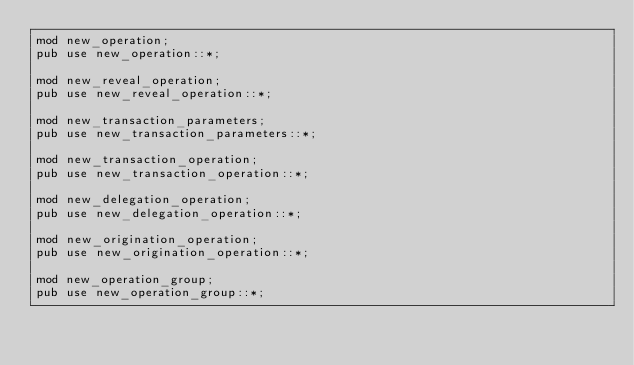Convert code to text. <code><loc_0><loc_0><loc_500><loc_500><_Rust_>mod new_operation;
pub use new_operation::*;

mod new_reveal_operation;
pub use new_reveal_operation::*;

mod new_transaction_parameters;
pub use new_transaction_parameters::*;

mod new_transaction_operation;
pub use new_transaction_operation::*;

mod new_delegation_operation;
pub use new_delegation_operation::*;

mod new_origination_operation;
pub use new_origination_operation::*;

mod new_operation_group;
pub use new_operation_group::*;
</code> 